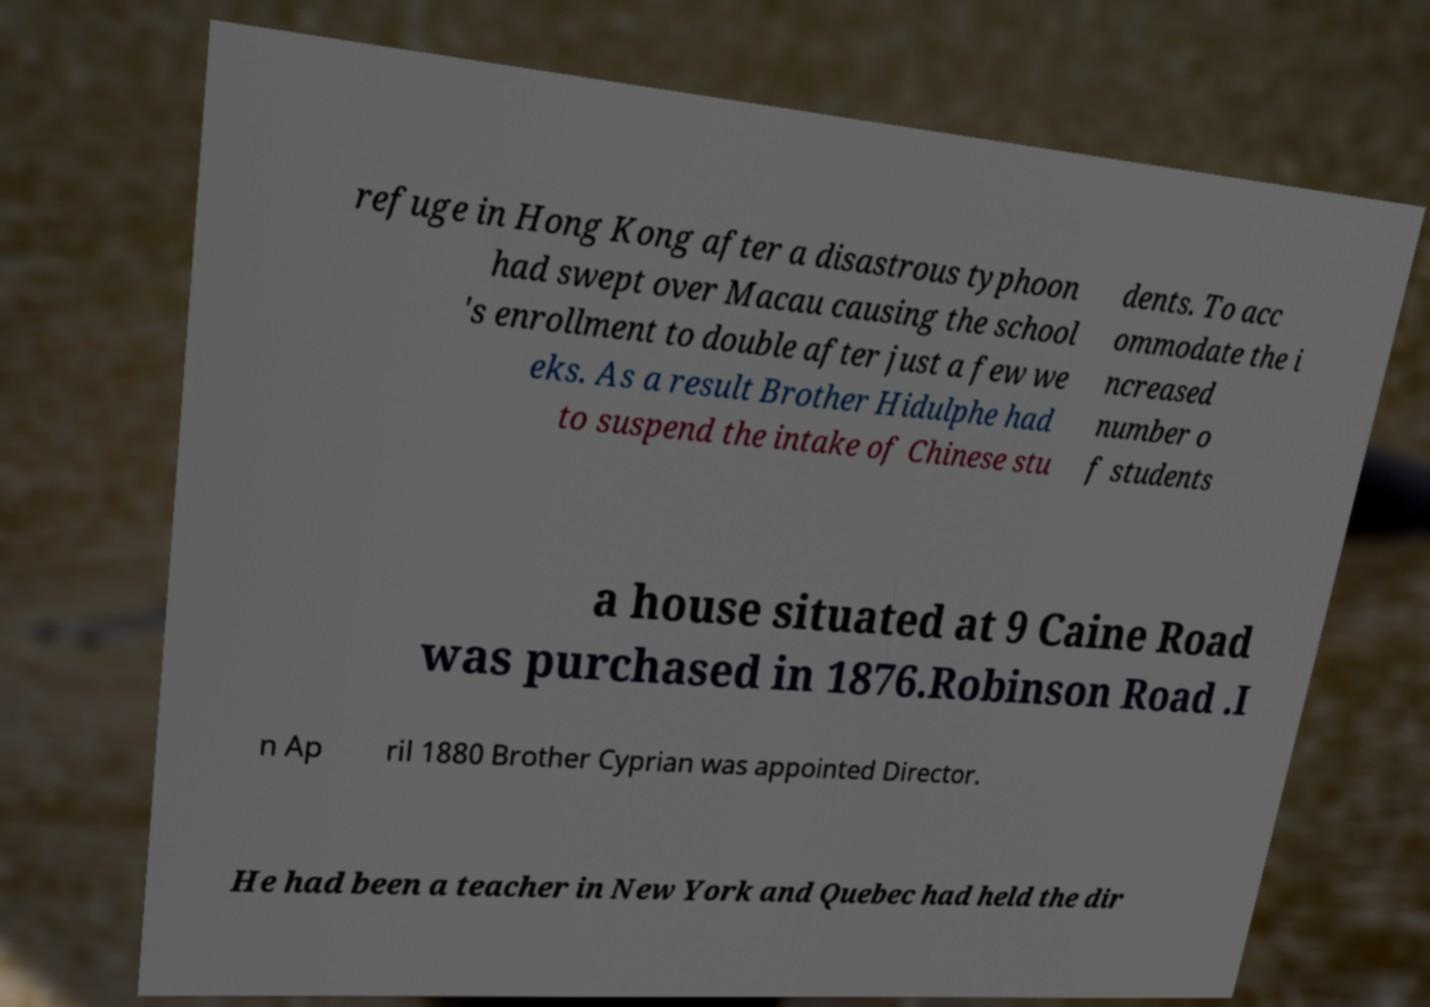Can you read and provide the text displayed in the image?This photo seems to have some interesting text. Can you extract and type it out for me? refuge in Hong Kong after a disastrous typhoon had swept over Macau causing the school 's enrollment to double after just a few we eks. As a result Brother Hidulphe had to suspend the intake of Chinese stu dents. To acc ommodate the i ncreased number o f students a house situated at 9 Caine Road was purchased in 1876.Robinson Road .I n Ap ril 1880 Brother Cyprian was appointed Director. He had been a teacher in New York and Quebec had held the dir 